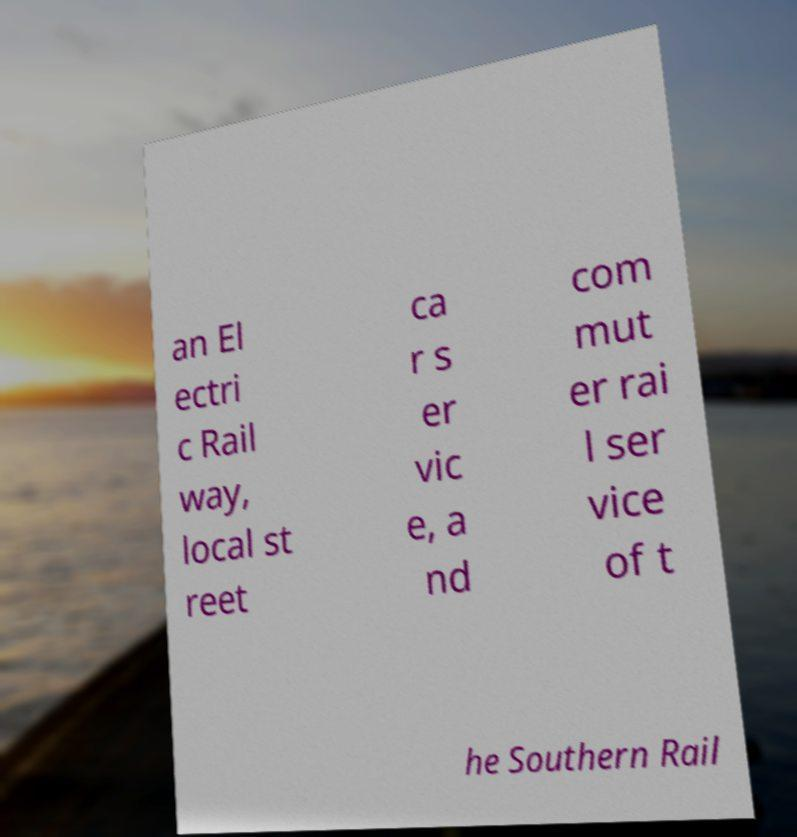Please identify and transcribe the text found in this image. an El ectri c Rail way, local st reet ca r s er vic e, a nd com mut er rai l ser vice of t he Southern Rail 